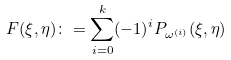Convert formula to latex. <formula><loc_0><loc_0><loc_500><loc_500>F ( \xi , \eta ) \colon = \sum _ { i = 0 } ^ { k } ( - 1 ) ^ { i } P _ { \omega ^ { ( i ) } } ( \xi , \eta )</formula> 